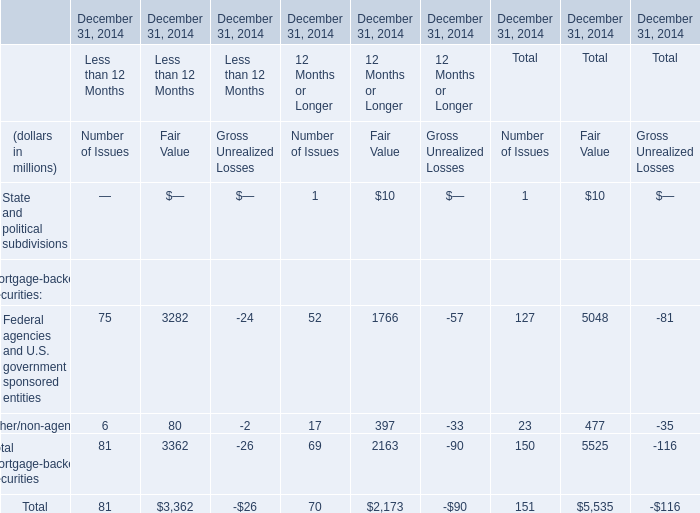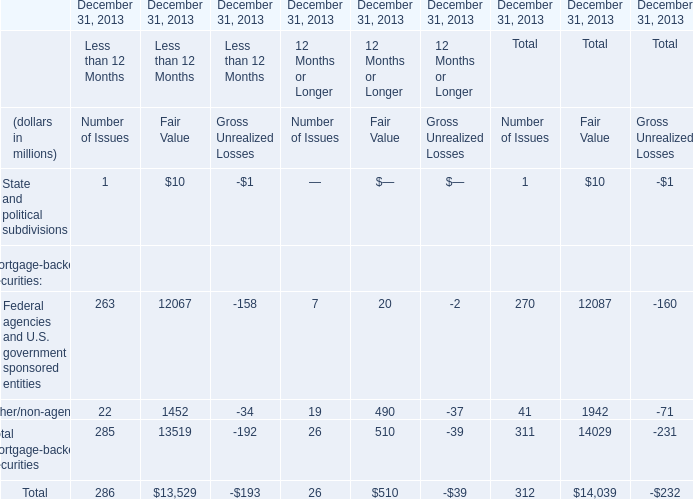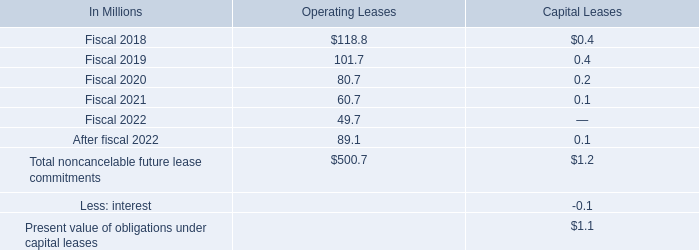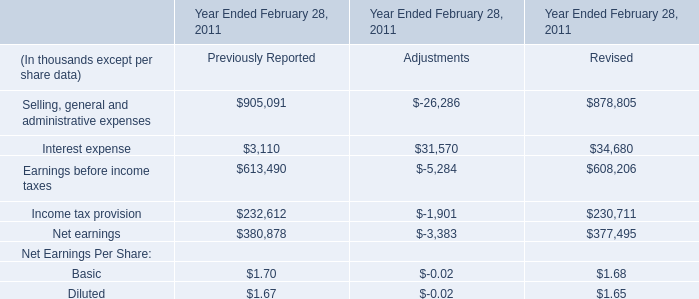Which section is Total mortgage-backed securities the highest? (in million) 
Answer: Less than 12 Months. 